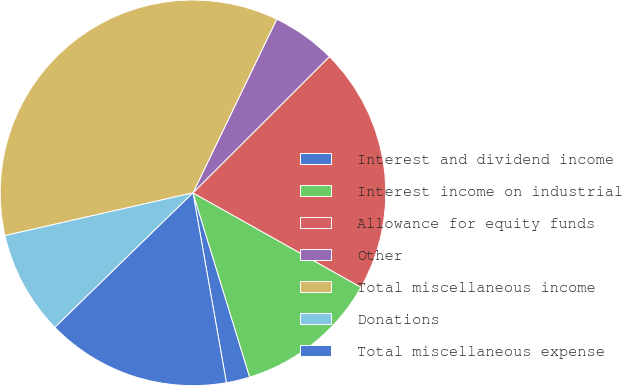Convert chart to OTSL. <chart><loc_0><loc_0><loc_500><loc_500><pie_chart><fcel>Interest and dividend income<fcel>Interest income on industrial<fcel>Allowance for equity funds<fcel>Other<fcel>Total miscellaneous income<fcel>Donations<fcel>Total miscellaneous expense<nl><fcel>1.98%<fcel>12.1%<fcel>20.63%<fcel>5.36%<fcel>35.71%<fcel>8.73%<fcel>15.48%<nl></chart> 